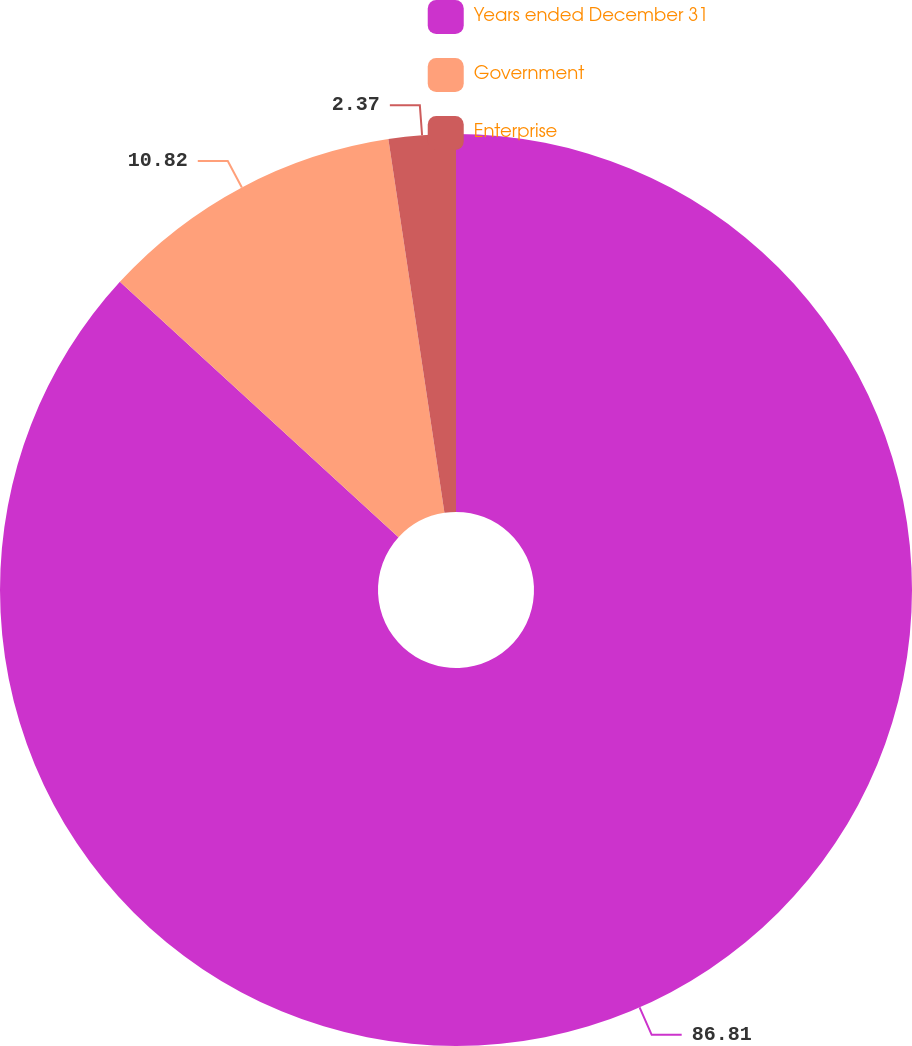Convert chart. <chart><loc_0><loc_0><loc_500><loc_500><pie_chart><fcel>Years ended December 31<fcel>Government<fcel>Enterprise<nl><fcel>86.81%<fcel>10.82%<fcel>2.37%<nl></chart> 